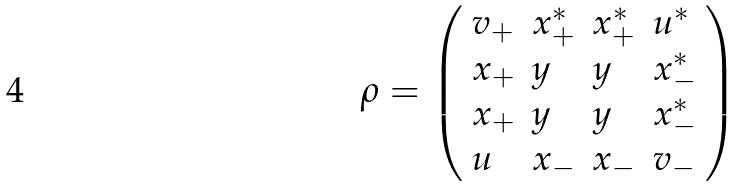<formula> <loc_0><loc_0><loc_500><loc_500>\rho = \left ( \begin{array} { l l l l } v _ { + } & x _ { + } ^ { * } & x _ { + } ^ { * } & u ^ { * } \\ x _ { + } & y & y & x _ { - } ^ { * } \\ x _ { + } & y & y & x _ { - } ^ { * } \\ u & x _ { - } & x _ { - } & v _ { - } \end{array} \right )</formula> 